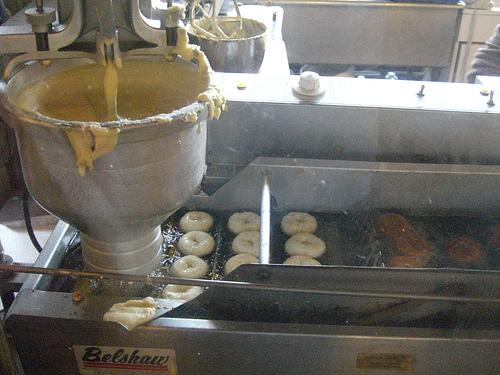Question: what is in the bowl?
Choices:
A. Batter.
B. Fruit.
C. Candy.
D. Applesauce.
Answer with the letter. Answer: A Question: how many unbaked doughnuts are there?
Choices:
A. 10.
B. 9.
C. 8.
D. 7.
Answer with the letter. Answer: A Question: where is the Belshaw label?
Choices:
A. To the side of the bowl.
B. On top of the bowl.
C. Under the bowl.
D. Beside the bowl.
Answer with the letter. Answer: C Question: what is the bowl made of?
Choices:
A. Plastic.
B. Metal.
C. Foam.
D. Steel.
Answer with the letter. Answer: B 